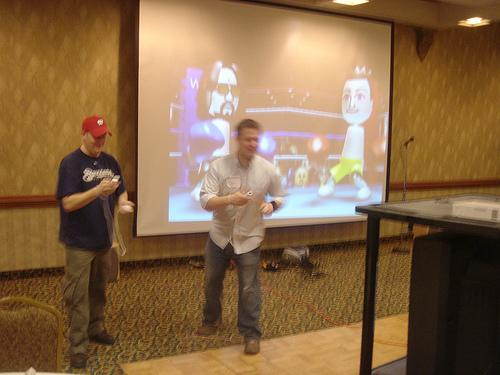Explain the sentiment that can be derived from the image. The sentiment derived from the image is fun and entertaining, as the two men are enjoying themselves playing a video game. Mention the type of electronic device present in the room and describe its appearance. There is a big TV projector screen with a game on it, a television set on a stand, and a Wii box game on top of the stand in the room. Identify the activity that two men are engaged in and describe their clothing. Two men are playing a Wii game, one of them wearing a blue shirt, a red cap, and brown cargo pants while the other one is wearing a white button-up shirt and blue jeans. Provide a brief overview of the room's decor and floor. The room has dark patterned wallpaper on the walls, wooden mat, and green and brown patterned carpet on the floor. 